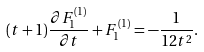<formula> <loc_0><loc_0><loc_500><loc_500>( t + 1 ) { \frac { \partial F _ { 1 } ^ { ( 1 ) } } { \partial t } } + F _ { 1 } ^ { ( 1 ) } = - { \frac { 1 } { 1 2 t ^ { 2 } } } .</formula> 